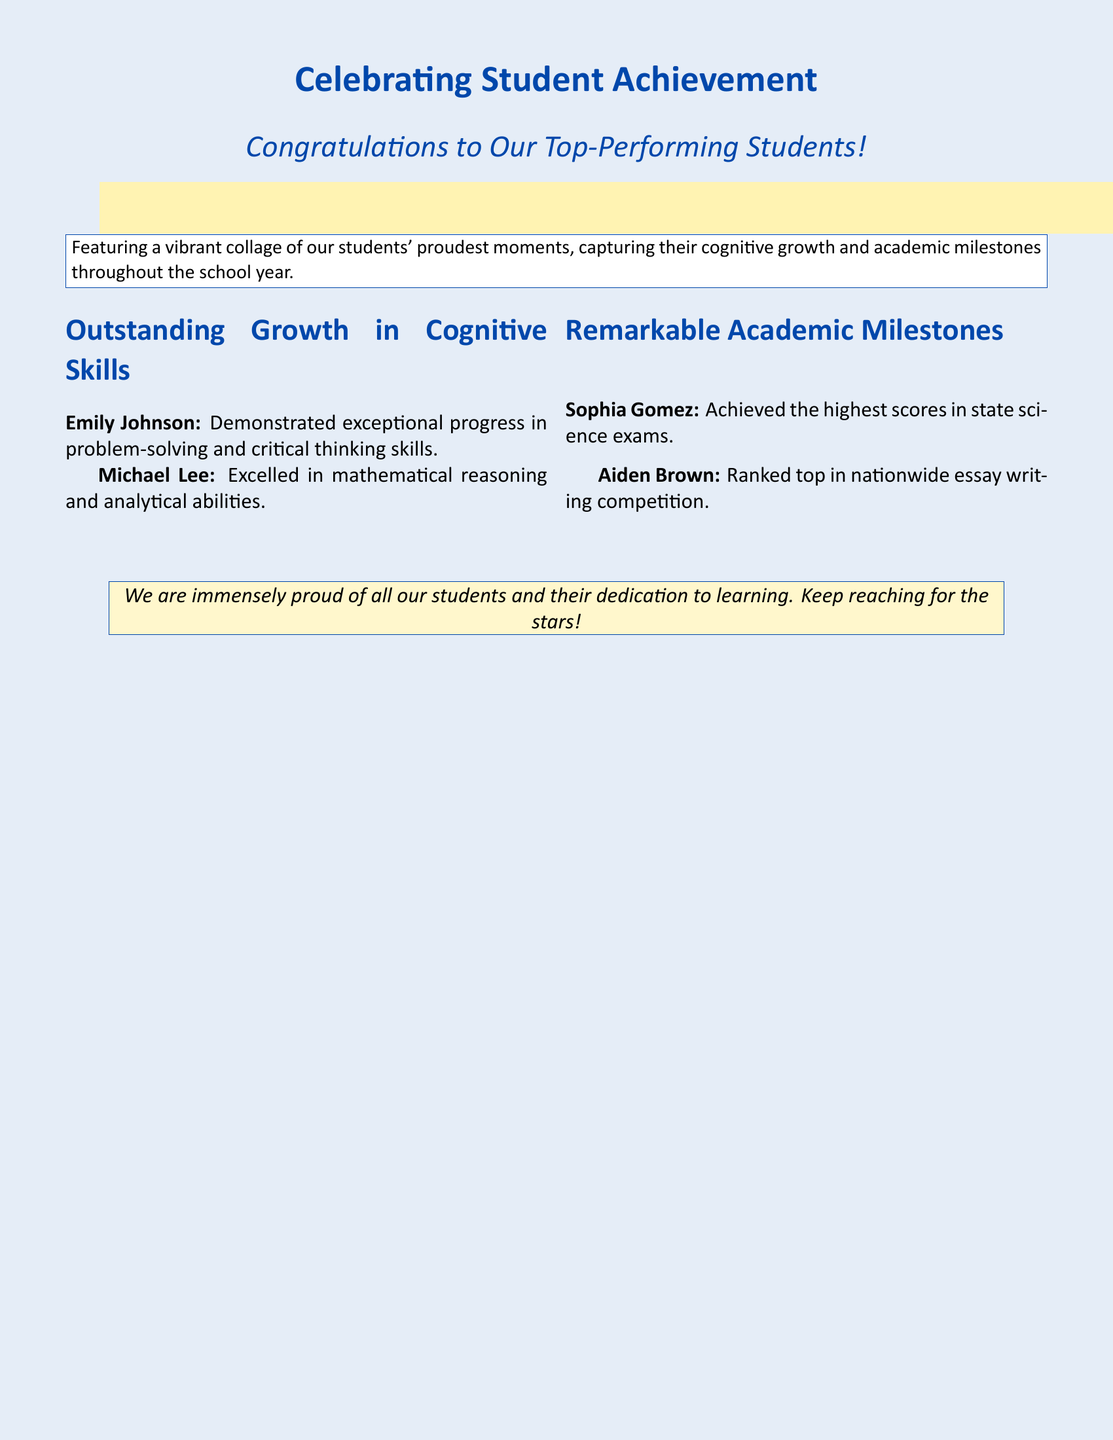What is the title of the card? The title of the card is stated clearly at the top, celebrating student achievement.
Answer: Celebrating Student Achievement Who is recognized for exceptional progress in problem-solving? The document specifies a student recognized for progressive skills, including problem-solving.
Answer: Emily Johnson What color is the background of the greeting card? The document describes the page color prominently used for the card's background.
Answer: Light blue Which student achieved the highest scores in state science exams? The document mentions one student who achieved the highest scores in a specific exam.
Answer: Sophia Gomez How many students are mentioned for their cognitive skills? The document lists students who have made significant progress in cognitive skills.
Answer: Two What is the congratulatory message's overall sentiment? The document conveys a sentiment reflecting pride and encouragement for students' efforts and achievements.
Answer: Proud Which type of skills did Michael Lee excel in? The document identifies specific types of skills for a student noted for their achievements.
Answer: Mathematical reasoning What is featured in the card alongside the students' achievements? The card highlights specific moments of cognitive growth and academic milestones.
Answer: Photo collage 